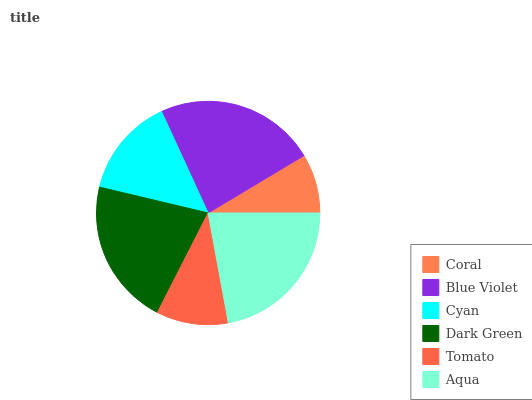Is Coral the minimum?
Answer yes or no. Yes. Is Blue Violet the maximum?
Answer yes or no. Yes. Is Cyan the minimum?
Answer yes or no. No. Is Cyan the maximum?
Answer yes or no. No. Is Blue Violet greater than Cyan?
Answer yes or no. Yes. Is Cyan less than Blue Violet?
Answer yes or no. Yes. Is Cyan greater than Blue Violet?
Answer yes or no. No. Is Blue Violet less than Cyan?
Answer yes or no. No. Is Dark Green the high median?
Answer yes or no. Yes. Is Cyan the low median?
Answer yes or no. Yes. Is Coral the high median?
Answer yes or no. No. Is Dark Green the low median?
Answer yes or no. No. 